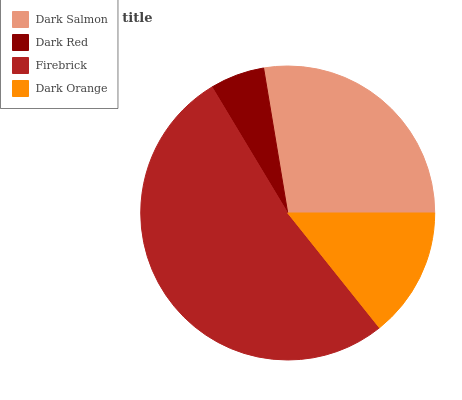Is Dark Red the minimum?
Answer yes or no. Yes. Is Firebrick the maximum?
Answer yes or no. Yes. Is Firebrick the minimum?
Answer yes or no. No. Is Dark Red the maximum?
Answer yes or no. No. Is Firebrick greater than Dark Red?
Answer yes or no. Yes. Is Dark Red less than Firebrick?
Answer yes or no. Yes. Is Dark Red greater than Firebrick?
Answer yes or no. No. Is Firebrick less than Dark Red?
Answer yes or no. No. Is Dark Salmon the high median?
Answer yes or no. Yes. Is Dark Orange the low median?
Answer yes or no. Yes. Is Dark Red the high median?
Answer yes or no. No. Is Dark Red the low median?
Answer yes or no. No. 